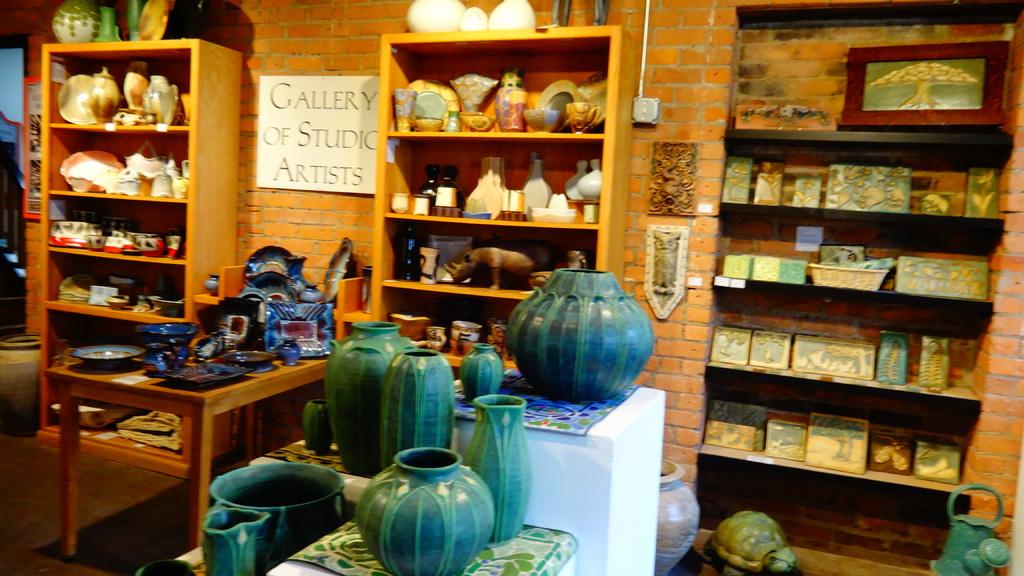What kind of gallery is this?
Your answer should be very brief. Studio artists. Which type of artists show their work here?
Offer a very short reply. Studio artists. 